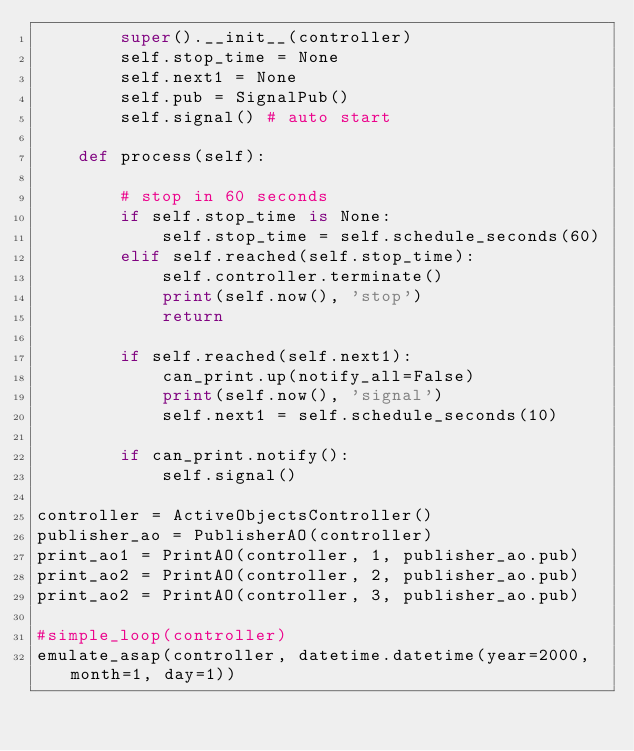<code> <loc_0><loc_0><loc_500><loc_500><_Python_>        super().__init__(controller)
        self.stop_time = None
        self.next1 = None
        self.pub = SignalPub()
        self.signal() # auto start

    def process(self):

        # stop in 60 seconds
        if self.stop_time is None:
            self.stop_time = self.schedule_seconds(60)
        elif self.reached(self.stop_time):
            self.controller.terminate()
            print(self.now(), 'stop')
            return

        if self.reached(self.next1):
            can_print.up(notify_all=False)
            print(self.now(), 'signal')
            self.next1 = self.schedule_seconds(10)

        if can_print.notify():
            self.signal()

controller = ActiveObjectsController()
publisher_ao = PublisherAO(controller)
print_ao1 = PrintAO(controller, 1, publisher_ao.pub)
print_ao2 = PrintAO(controller, 2, publisher_ao.pub)
print_ao2 = PrintAO(controller, 3, publisher_ao.pub)

#simple_loop(controller)
emulate_asap(controller, datetime.datetime(year=2000, month=1, day=1))
</code> 